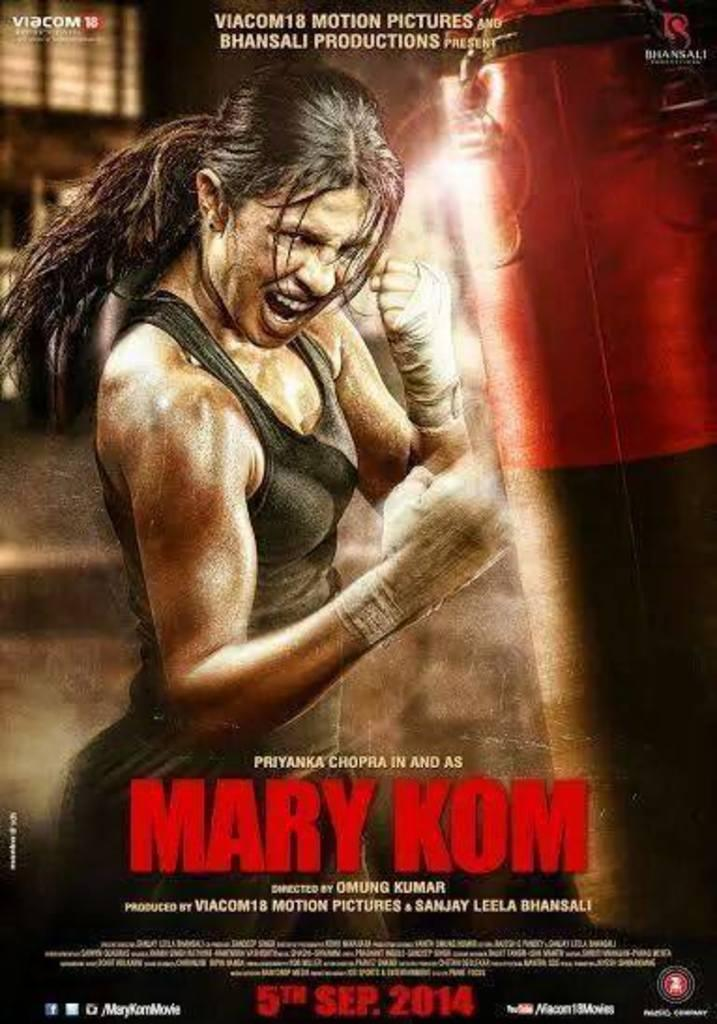<image>
Present a compact description of the photo's key features. a movie poster with a woman boxing title mary Kom 